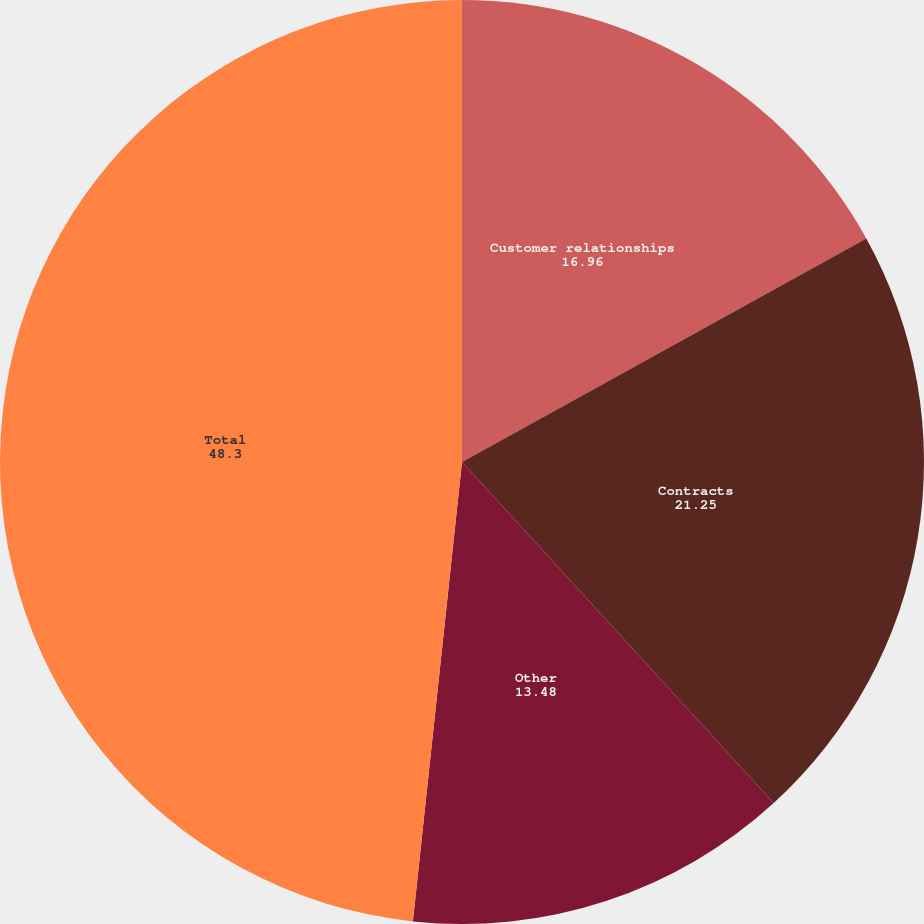Convert chart to OTSL. <chart><loc_0><loc_0><loc_500><loc_500><pie_chart><fcel>Customer relationships<fcel>Contracts<fcel>Other<fcel>Total<nl><fcel>16.96%<fcel>21.25%<fcel>13.48%<fcel>48.3%<nl></chart> 